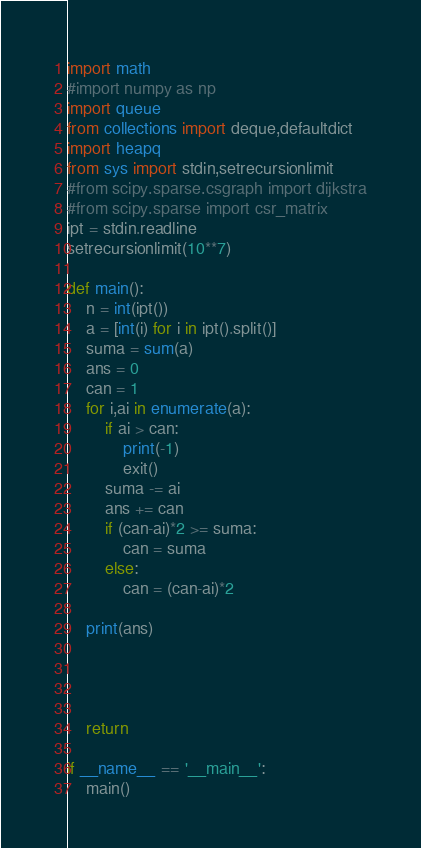Convert code to text. <code><loc_0><loc_0><loc_500><loc_500><_Python_>import math
#import numpy as np
import queue
from collections import deque,defaultdict
import heapq
from sys import stdin,setrecursionlimit
#from scipy.sparse.csgraph import dijkstra
#from scipy.sparse import csr_matrix
ipt = stdin.readline
setrecursionlimit(10**7)

def main():
    n = int(ipt())
    a = [int(i) for i in ipt().split()]
    suma = sum(a)
    ans = 0
    can = 1
    for i,ai in enumerate(a):
        if ai > can:
            print(-1)
            exit()
        suma -= ai
        ans += can
        if (can-ai)*2 >= suma:
            can = suma
        else:
            can = (can-ai)*2

    print(ans)




    return

if __name__ == '__main__':
    main()
</code> 